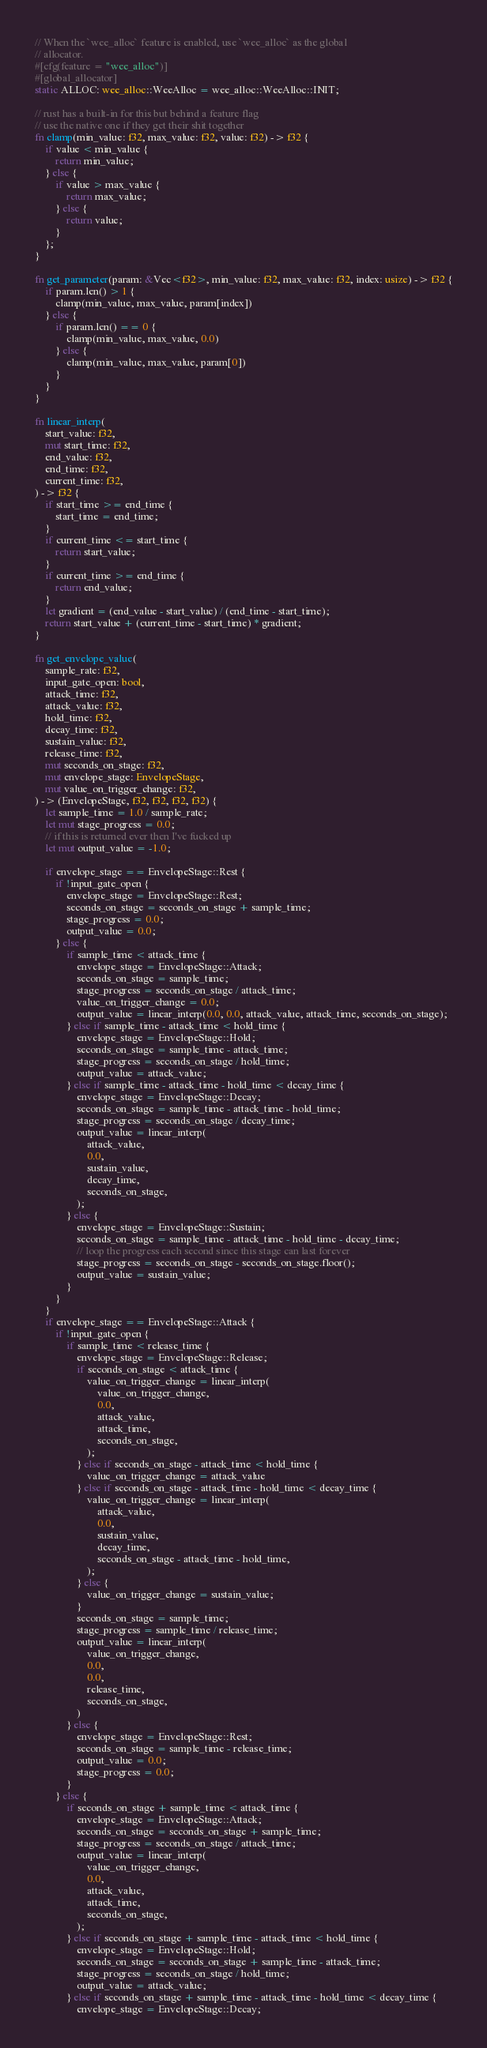<code> <loc_0><loc_0><loc_500><loc_500><_Rust_>// When the `wee_alloc` feature is enabled, use `wee_alloc` as the global
// allocator.
#[cfg(feature = "wee_alloc")]
#[global_allocator]
static ALLOC: wee_alloc::WeeAlloc = wee_alloc::WeeAlloc::INIT;

// rust has a built-in for this but behind a feature flag
// use the native one if they get their shit together
fn clamp(min_value: f32, max_value: f32, value: f32) -> f32 {
	if value < min_value {
		return min_value;
	} else {
		if value > max_value {
			return max_value;
		} else {
			return value;
		}
	};
}

fn get_parameter(param: &Vec<f32>, min_value: f32, max_value: f32, index: usize) -> f32 {
	if param.len() > 1 {
		clamp(min_value, max_value, param[index])
	} else {
		if param.len() == 0 {
			clamp(min_value, max_value, 0.0)
		} else {
			clamp(min_value, max_value, param[0])
		}
	}
}

fn linear_interp(
	start_value: f32,
	mut start_time: f32,
	end_value: f32,
	end_time: f32,
	current_time: f32,
) -> f32 {
	if start_time >= end_time {
		start_time = end_time;
	}
	if current_time <= start_time {
		return start_value;
	}
	if current_time >= end_time {
		return end_value;
	}
	let gradient = (end_value - start_value) / (end_time - start_time);
	return start_value + (current_time - start_time) * gradient;
}

fn get_envelope_value(
	sample_rate: f32,
	input_gate_open: bool,
	attack_time: f32,
	attack_value: f32,
	hold_time: f32,
	decay_time: f32,
	sustain_value: f32,
	release_time: f32,
	mut seconds_on_stage: f32,
	mut envelope_stage: EnvelopeStage,
	mut value_on_trigger_change: f32,
) -> (EnvelopeStage, f32, f32, f32, f32) {
	let sample_time = 1.0 / sample_rate;
	let mut stage_progress = 0.0;
	// if this is returned ever then I've fucked up
	let mut output_value = -1.0;

	if envelope_stage == EnvelopeStage::Rest {
		if !input_gate_open {
			envelope_stage = EnvelopeStage::Rest;
			seconds_on_stage = seconds_on_stage + sample_time;
			stage_progress = 0.0;
			output_value = 0.0;
		} else {
			if sample_time < attack_time {
				envelope_stage = EnvelopeStage::Attack;
				seconds_on_stage = sample_time;
				stage_progress = seconds_on_stage / attack_time;
				value_on_trigger_change = 0.0;
				output_value = linear_interp(0.0, 0.0, attack_value, attack_time, seconds_on_stage);
			} else if sample_time - attack_time < hold_time {
				envelope_stage = EnvelopeStage::Hold;
				seconds_on_stage = sample_time - attack_time;
				stage_progress = seconds_on_stage / hold_time;
				output_value = attack_value;
			} else if sample_time - attack_time - hold_time < decay_time {
				envelope_stage = EnvelopeStage::Decay;
				seconds_on_stage = sample_time - attack_time - hold_time;
				stage_progress = seconds_on_stage / decay_time;
				output_value = linear_interp(
					attack_value,
					0.0,
					sustain_value,
					decay_time,
					seconds_on_stage,
				);
			} else {
				envelope_stage = EnvelopeStage::Sustain;
				seconds_on_stage = sample_time - attack_time - hold_time - decay_time;
				// loop the progress each second since this stage can last forever
				stage_progress = seconds_on_stage - seconds_on_stage.floor();
				output_value = sustain_value;
			}
		}
	}
	if envelope_stage == EnvelopeStage::Attack {
		if !input_gate_open {
			if sample_time < release_time {
				envelope_stage = EnvelopeStage::Release;
				if seconds_on_stage < attack_time {
					value_on_trigger_change = linear_interp(
						value_on_trigger_change,
						0.0,
						attack_value,
						attack_time,
						seconds_on_stage,
					);
				} else if seconds_on_stage - attack_time < hold_time {
					value_on_trigger_change = attack_value
				} else if seconds_on_stage - attack_time - hold_time < decay_time {
					value_on_trigger_change = linear_interp(
						attack_value,
						0.0,
						sustain_value,
						decay_time,
						seconds_on_stage - attack_time - hold_time,
					);
				} else {
					value_on_trigger_change = sustain_value;
				}
				seconds_on_stage = sample_time;
				stage_progress = sample_time / release_time;
				output_value = linear_interp(
					value_on_trigger_change,
					0.0,
					0.0,
					release_time,
					seconds_on_stage,
				)
			} else {
				envelope_stage = EnvelopeStage::Rest;
				seconds_on_stage = sample_time - release_time;
				output_value = 0.0;
				stage_progress = 0.0;
			}
		} else {
			if seconds_on_stage + sample_time < attack_time {
				envelope_stage = EnvelopeStage::Attack;
				seconds_on_stage = seconds_on_stage + sample_time;
				stage_progress = seconds_on_stage / attack_time;
				output_value = linear_interp(
					value_on_trigger_change,
					0.0,
					attack_value,
					attack_time,
					seconds_on_stage,
				);
			} else if seconds_on_stage + sample_time - attack_time < hold_time {
				envelope_stage = EnvelopeStage::Hold;
				seconds_on_stage = seconds_on_stage + sample_time - attack_time;
				stage_progress = seconds_on_stage / hold_time;
				output_value = attack_value;
			} else if seconds_on_stage + sample_time - attack_time - hold_time < decay_time {
				envelope_stage = EnvelopeStage::Decay;</code> 